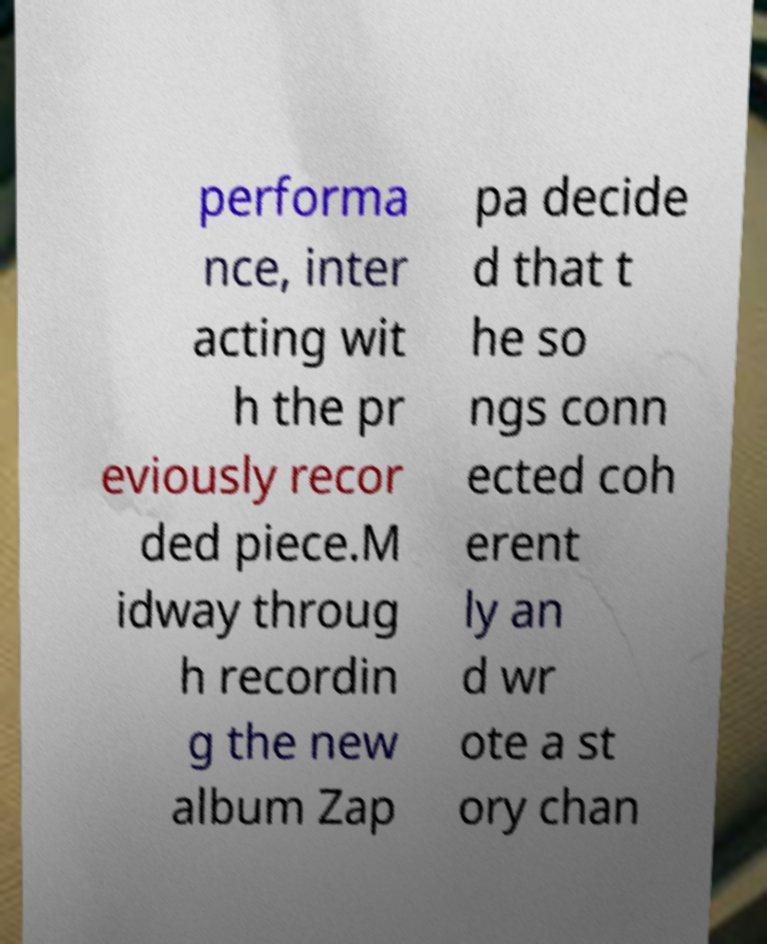Can you accurately transcribe the text from the provided image for me? performa nce, inter acting wit h the pr eviously recor ded piece.M idway throug h recordin g the new album Zap pa decide d that t he so ngs conn ected coh erent ly an d wr ote a st ory chan 